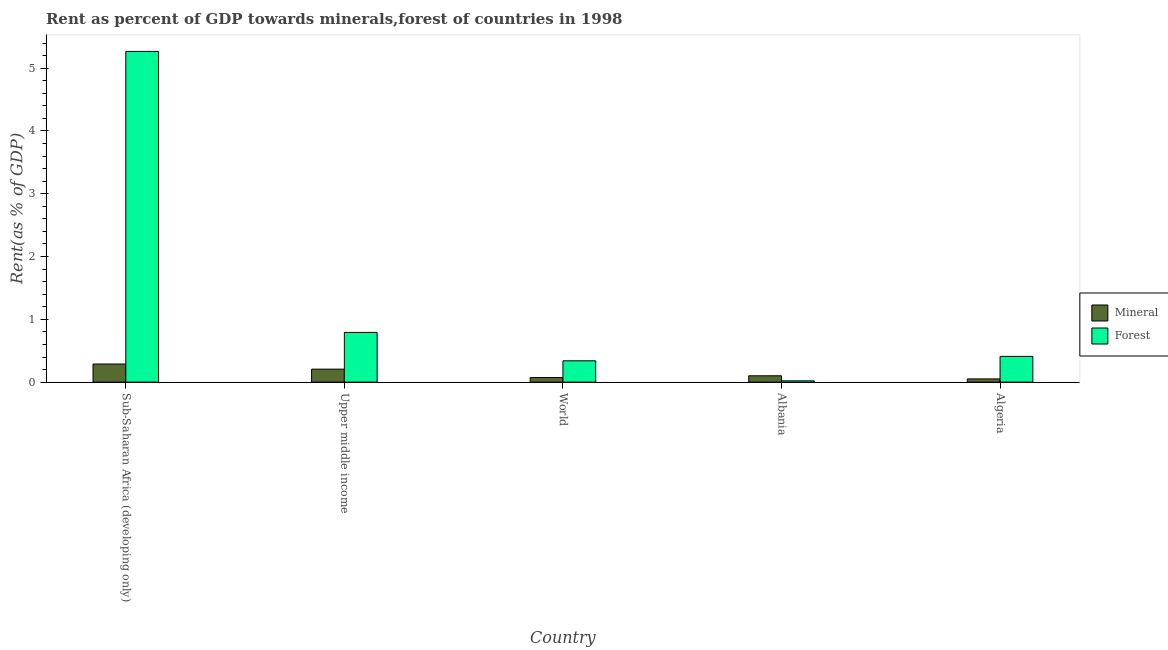How many different coloured bars are there?
Give a very brief answer. 2. Are the number of bars on each tick of the X-axis equal?
Your answer should be compact. Yes. How many bars are there on the 5th tick from the right?
Your response must be concise. 2. What is the label of the 5th group of bars from the left?
Give a very brief answer. Algeria. What is the forest rent in World?
Provide a succinct answer. 0.34. Across all countries, what is the maximum forest rent?
Your response must be concise. 5.27. Across all countries, what is the minimum forest rent?
Provide a succinct answer. 0.02. In which country was the mineral rent maximum?
Provide a succinct answer. Sub-Saharan Africa (developing only). In which country was the forest rent minimum?
Offer a very short reply. Albania. What is the total mineral rent in the graph?
Provide a succinct answer. 0.72. What is the difference between the mineral rent in Algeria and that in World?
Keep it short and to the point. -0.02. What is the difference between the mineral rent in Algeria and the forest rent in Upper middle income?
Provide a short and direct response. -0.74. What is the average mineral rent per country?
Offer a terse response. 0.14. What is the difference between the mineral rent and forest rent in World?
Offer a terse response. -0.27. What is the ratio of the forest rent in Algeria to that in Sub-Saharan Africa (developing only)?
Your answer should be very brief. 0.08. Is the forest rent in Algeria less than that in Sub-Saharan Africa (developing only)?
Make the answer very short. Yes. What is the difference between the highest and the second highest forest rent?
Ensure brevity in your answer.  4.47. What is the difference between the highest and the lowest forest rent?
Your response must be concise. 5.25. What does the 2nd bar from the left in Upper middle income represents?
Make the answer very short. Forest. What does the 2nd bar from the right in Sub-Saharan Africa (developing only) represents?
Ensure brevity in your answer.  Mineral. How many bars are there?
Your answer should be compact. 10. Are all the bars in the graph horizontal?
Your answer should be very brief. No. How many countries are there in the graph?
Make the answer very short. 5. Are the values on the major ticks of Y-axis written in scientific E-notation?
Your answer should be compact. No. Where does the legend appear in the graph?
Your answer should be very brief. Center right. What is the title of the graph?
Your response must be concise. Rent as percent of GDP towards minerals,forest of countries in 1998. Does "Passenger Transport Items" appear as one of the legend labels in the graph?
Provide a short and direct response. No. What is the label or title of the Y-axis?
Provide a succinct answer. Rent(as % of GDP). What is the Rent(as % of GDP) of Mineral in Sub-Saharan Africa (developing only)?
Your answer should be compact. 0.29. What is the Rent(as % of GDP) in Forest in Sub-Saharan Africa (developing only)?
Offer a very short reply. 5.27. What is the Rent(as % of GDP) in Mineral in Upper middle income?
Your answer should be very brief. 0.21. What is the Rent(as % of GDP) in Forest in Upper middle income?
Your answer should be very brief. 0.79. What is the Rent(as % of GDP) of Mineral in World?
Your response must be concise. 0.07. What is the Rent(as % of GDP) of Forest in World?
Keep it short and to the point. 0.34. What is the Rent(as % of GDP) in Mineral in Albania?
Ensure brevity in your answer.  0.1. What is the Rent(as % of GDP) of Forest in Albania?
Ensure brevity in your answer.  0.02. What is the Rent(as % of GDP) in Mineral in Algeria?
Your response must be concise. 0.05. What is the Rent(as % of GDP) in Forest in Algeria?
Give a very brief answer. 0.41. Across all countries, what is the maximum Rent(as % of GDP) in Mineral?
Keep it short and to the point. 0.29. Across all countries, what is the maximum Rent(as % of GDP) of Forest?
Offer a very short reply. 5.27. Across all countries, what is the minimum Rent(as % of GDP) of Mineral?
Your answer should be compact. 0.05. Across all countries, what is the minimum Rent(as % of GDP) of Forest?
Ensure brevity in your answer.  0.02. What is the total Rent(as % of GDP) of Mineral in the graph?
Offer a very short reply. 0.72. What is the total Rent(as % of GDP) in Forest in the graph?
Offer a terse response. 6.83. What is the difference between the Rent(as % of GDP) of Mineral in Sub-Saharan Africa (developing only) and that in Upper middle income?
Offer a terse response. 0.08. What is the difference between the Rent(as % of GDP) in Forest in Sub-Saharan Africa (developing only) and that in Upper middle income?
Your response must be concise. 4.47. What is the difference between the Rent(as % of GDP) in Mineral in Sub-Saharan Africa (developing only) and that in World?
Offer a terse response. 0.22. What is the difference between the Rent(as % of GDP) in Forest in Sub-Saharan Africa (developing only) and that in World?
Offer a very short reply. 4.93. What is the difference between the Rent(as % of GDP) in Mineral in Sub-Saharan Africa (developing only) and that in Albania?
Ensure brevity in your answer.  0.19. What is the difference between the Rent(as % of GDP) of Forest in Sub-Saharan Africa (developing only) and that in Albania?
Keep it short and to the point. 5.25. What is the difference between the Rent(as % of GDP) of Mineral in Sub-Saharan Africa (developing only) and that in Algeria?
Keep it short and to the point. 0.24. What is the difference between the Rent(as % of GDP) in Forest in Sub-Saharan Africa (developing only) and that in Algeria?
Ensure brevity in your answer.  4.86. What is the difference between the Rent(as % of GDP) in Mineral in Upper middle income and that in World?
Your answer should be very brief. 0.13. What is the difference between the Rent(as % of GDP) in Forest in Upper middle income and that in World?
Your answer should be very brief. 0.45. What is the difference between the Rent(as % of GDP) in Mineral in Upper middle income and that in Albania?
Ensure brevity in your answer.  0.11. What is the difference between the Rent(as % of GDP) in Forest in Upper middle income and that in Albania?
Your answer should be very brief. 0.77. What is the difference between the Rent(as % of GDP) in Mineral in Upper middle income and that in Algeria?
Make the answer very short. 0.16. What is the difference between the Rent(as % of GDP) in Forest in Upper middle income and that in Algeria?
Keep it short and to the point. 0.38. What is the difference between the Rent(as % of GDP) in Mineral in World and that in Albania?
Ensure brevity in your answer.  -0.03. What is the difference between the Rent(as % of GDP) in Forest in World and that in Albania?
Provide a short and direct response. 0.32. What is the difference between the Rent(as % of GDP) of Mineral in World and that in Algeria?
Give a very brief answer. 0.02. What is the difference between the Rent(as % of GDP) in Forest in World and that in Algeria?
Provide a short and direct response. -0.07. What is the difference between the Rent(as % of GDP) in Mineral in Albania and that in Algeria?
Offer a very short reply. 0.05. What is the difference between the Rent(as % of GDP) in Forest in Albania and that in Algeria?
Your response must be concise. -0.39. What is the difference between the Rent(as % of GDP) of Mineral in Sub-Saharan Africa (developing only) and the Rent(as % of GDP) of Forest in Upper middle income?
Your response must be concise. -0.5. What is the difference between the Rent(as % of GDP) in Mineral in Sub-Saharan Africa (developing only) and the Rent(as % of GDP) in Forest in World?
Offer a terse response. -0.05. What is the difference between the Rent(as % of GDP) in Mineral in Sub-Saharan Africa (developing only) and the Rent(as % of GDP) in Forest in Albania?
Provide a short and direct response. 0.27. What is the difference between the Rent(as % of GDP) in Mineral in Sub-Saharan Africa (developing only) and the Rent(as % of GDP) in Forest in Algeria?
Ensure brevity in your answer.  -0.12. What is the difference between the Rent(as % of GDP) in Mineral in Upper middle income and the Rent(as % of GDP) in Forest in World?
Offer a terse response. -0.13. What is the difference between the Rent(as % of GDP) of Mineral in Upper middle income and the Rent(as % of GDP) of Forest in Albania?
Offer a very short reply. 0.19. What is the difference between the Rent(as % of GDP) of Mineral in Upper middle income and the Rent(as % of GDP) of Forest in Algeria?
Your answer should be very brief. -0.2. What is the difference between the Rent(as % of GDP) of Mineral in World and the Rent(as % of GDP) of Forest in Albania?
Offer a terse response. 0.05. What is the difference between the Rent(as % of GDP) of Mineral in World and the Rent(as % of GDP) of Forest in Algeria?
Your answer should be very brief. -0.34. What is the difference between the Rent(as % of GDP) in Mineral in Albania and the Rent(as % of GDP) in Forest in Algeria?
Your response must be concise. -0.31. What is the average Rent(as % of GDP) in Mineral per country?
Ensure brevity in your answer.  0.14. What is the average Rent(as % of GDP) in Forest per country?
Give a very brief answer. 1.37. What is the difference between the Rent(as % of GDP) in Mineral and Rent(as % of GDP) in Forest in Sub-Saharan Africa (developing only)?
Your answer should be very brief. -4.98. What is the difference between the Rent(as % of GDP) of Mineral and Rent(as % of GDP) of Forest in Upper middle income?
Your response must be concise. -0.58. What is the difference between the Rent(as % of GDP) in Mineral and Rent(as % of GDP) in Forest in World?
Your answer should be very brief. -0.27. What is the difference between the Rent(as % of GDP) in Mineral and Rent(as % of GDP) in Forest in Albania?
Give a very brief answer. 0.08. What is the difference between the Rent(as % of GDP) in Mineral and Rent(as % of GDP) in Forest in Algeria?
Your response must be concise. -0.36. What is the ratio of the Rent(as % of GDP) in Mineral in Sub-Saharan Africa (developing only) to that in Upper middle income?
Make the answer very short. 1.39. What is the ratio of the Rent(as % of GDP) in Forest in Sub-Saharan Africa (developing only) to that in Upper middle income?
Provide a short and direct response. 6.65. What is the ratio of the Rent(as % of GDP) of Mineral in Sub-Saharan Africa (developing only) to that in World?
Give a very brief answer. 3.95. What is the ratio of the Rent(as % of GDP) of Forest in Sub-Saharan Africa (developing only) to that in World?
Your answer should be very brief. 15.5. What is the ratio of the Rent(as % of GDP) in Mineral in Sub-Saharan Africa (developing only) to that in Albania?
Offer a terse response. 2.85. What is the ratio of the Rent(as % of GDP) of Forest in Sub-Saharan Africa (developing only) to that in Albania?
Provide a succinct answer. 256.33. What is the ratio of the Rent(as % of GDP) of Mineral in Sub-Saharan Africa (developing only) to that in Algeria?
Offer a terse response. 5.59. What is the ratio of the Rent(as % of GDP) in Forest in Sub-Saharan Africa (developing only) to that in Algeria?
Your answer should be very brief. 12.84. What is the ratio of the Rent(as % of GDP) in Mineral in Upper middle income to that in World?
Provide a succinct answer. 2.83. What is the ratio of the Rent(as % of GDP) of Forest in Upper middle income to that in World?
Your answer should be very brief. 2.33. What is the ratio of the Rent(as % of GDP) of Mineral in Upper middle income to that in Albania?
Provide a succinct answer. 2.04. What is the ratio of the Rent(as % of GDP) in Forest in Upper middle income to that in Albania?
Give a very brief answer. 38.54. What is the ratio of the Rent(as % of GDP) in Mineral in Upper middle income to that in Algeria?
Offer a terse response. 4.01. What is the ratio of the Rent(as % of GDP) in Forest in Upper middle income to that in Algeria?
Offer a very short reply. 1.93. What is the ratio of the Rent(as % of GDP) in Mineral in World to that in Albania?
Provide a succinct answer. 0.72. What is the ratio of the Rent(as % of GDP) of Forest in World to that in Albania?
Provide a succinct answer. 16.54. What is the ratio of the Rent(as % of GDP) of Mineral in World to that in Algeria?
Your response must be concise. 1.42. What is the ratio of the Rent(as % of GDP) in Forest in World to that in Algeria?
Your answer should be compact. 0.83. What is the ratio of the Rent(as % of GDP) in Mineral in Albania to that in Algeria?
Provide a short and direct response. 1.96. What is the ratio of the Rent(as % of GDP) in Forest in Albania to that in Algeria?
Your answer should be compact. 0.05. What is the difference between the highest and the second highest Rent(as % of GDP) in Mineral?
Offer a terse response. 0.08. What is the difference between the highest and the second highest Rent(as % of GDP) of Forest?
Ensure brevity in your answer.  4.47. What is the difference between the highest and the lowest Rent(as % of GDP) in Mineral?
Ensure brevity in your answer.  0.24. What is the difference between the highest and the lowest Rent(as % of GDP) of Forest?
Offer a terse response. 5.25. 